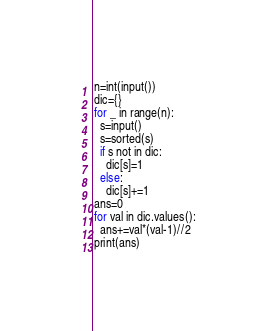Convert code to text. <code><loc_0><loc_0><loc_500><loc_500><_Python_>n=int(input())
dic={}
for _ in range(n):
  s=input()
  s=sorted(s)
  if s not in dic:
    dic[s]=1
  else:
    dic[s]+=1
ans=0
for val in dic.values():
  ans+=val*(val-1)//2
print(ans)</code> 